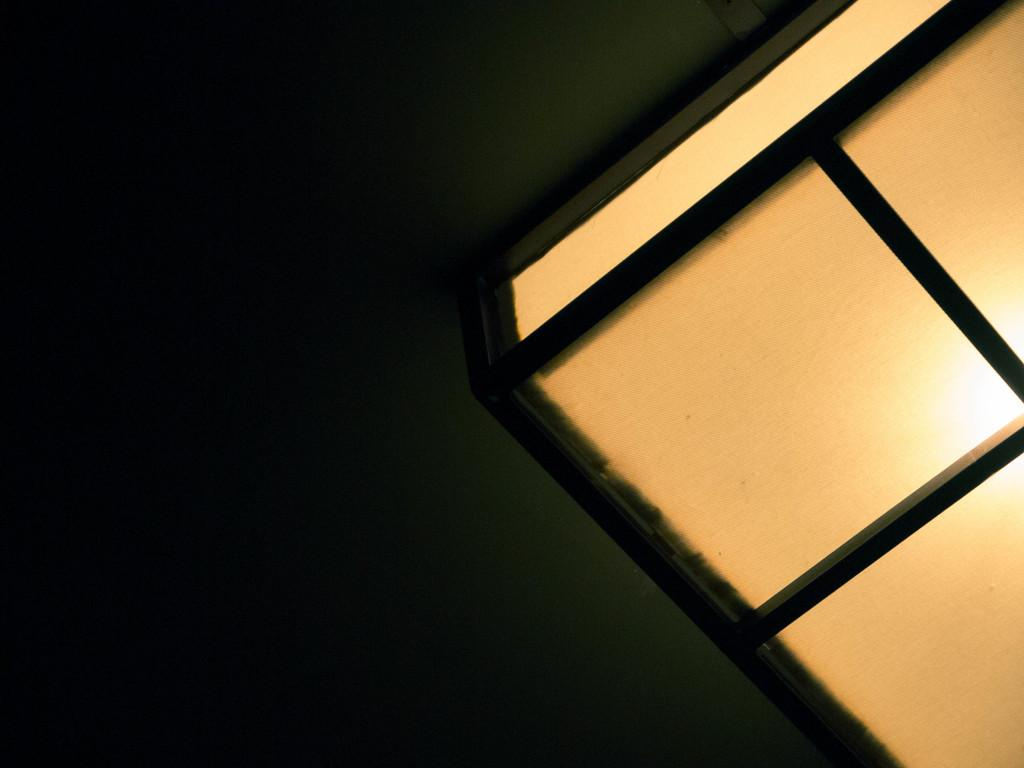What is located on the right side of the image? There is a light on the right side of the image. What can be seen on the left side of the image? There is a dark green background on the left side of the image. What type of advice can be seen in the image? There is no advice present in the image; it only features a light on the right side and a dark green background on the left side. Is there a jail visible in the image? No, there is no jail present in the image. 